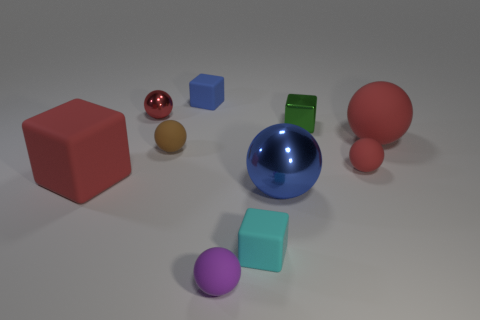There is a small cube in front of the shiny sphere on the right side of the rubber block to the right of the blue matte cube; what is its material? The small cube in front of the shiny sphere, situated on the right side of the rubber block and to the right of the blue matte cube, appears to be made of the same matte material as the blue cube, but without a closer examination it's not possible to determine its exact composition. 